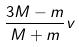<formula> <loc_0><loc_0><loc_500><loc_500>\frac { 3 M - m } { M + m } v</formula> 